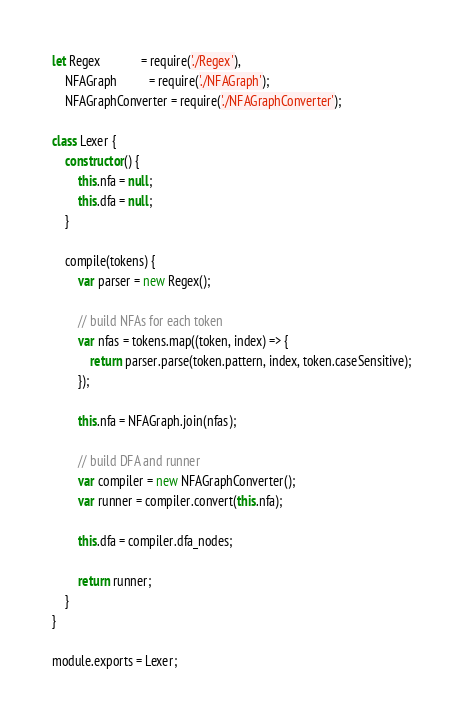Convert code to text. <code><loc_0><loc_0><loc_500><loc_500><_JavaScript_>let Regex             = require('./Regex'),
    NFAGraph          = require('./NFAGraph');
    NFAGraphConverter = require('./NFAGraphConverter');

class Lexer {
    constructor() {
        this.nfa = null;
        this.dfa = null;
    }

    compile(tokens) {
        var parser = new Regex();

        // build NFAs for each token
        var nfas = tokens.map((token, index) => {
            return parser.parse(token.pattern, index, token.caseSensitive);
        });

        this.nfa = NFAGraph.join(nfas);

        // build DFA and runner
        var compiler = new NFAGraphConverter();
        var runner = compiler.convert(this.nfa);

        this.dfa = compiler.dfa_nodes;

        return runner;
    }
}

module.exports = Lexer;
</code> 